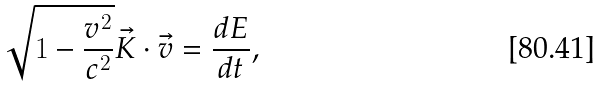<formula> <loc_0><loc_0><loc_500><loc_500>\sqrt { 1 - \frac { v ^ { 2 } } { c ^ { 2 } } } \vec { K } \cdot \vec { v } = \frac { d E } { d t } ,</formula> 